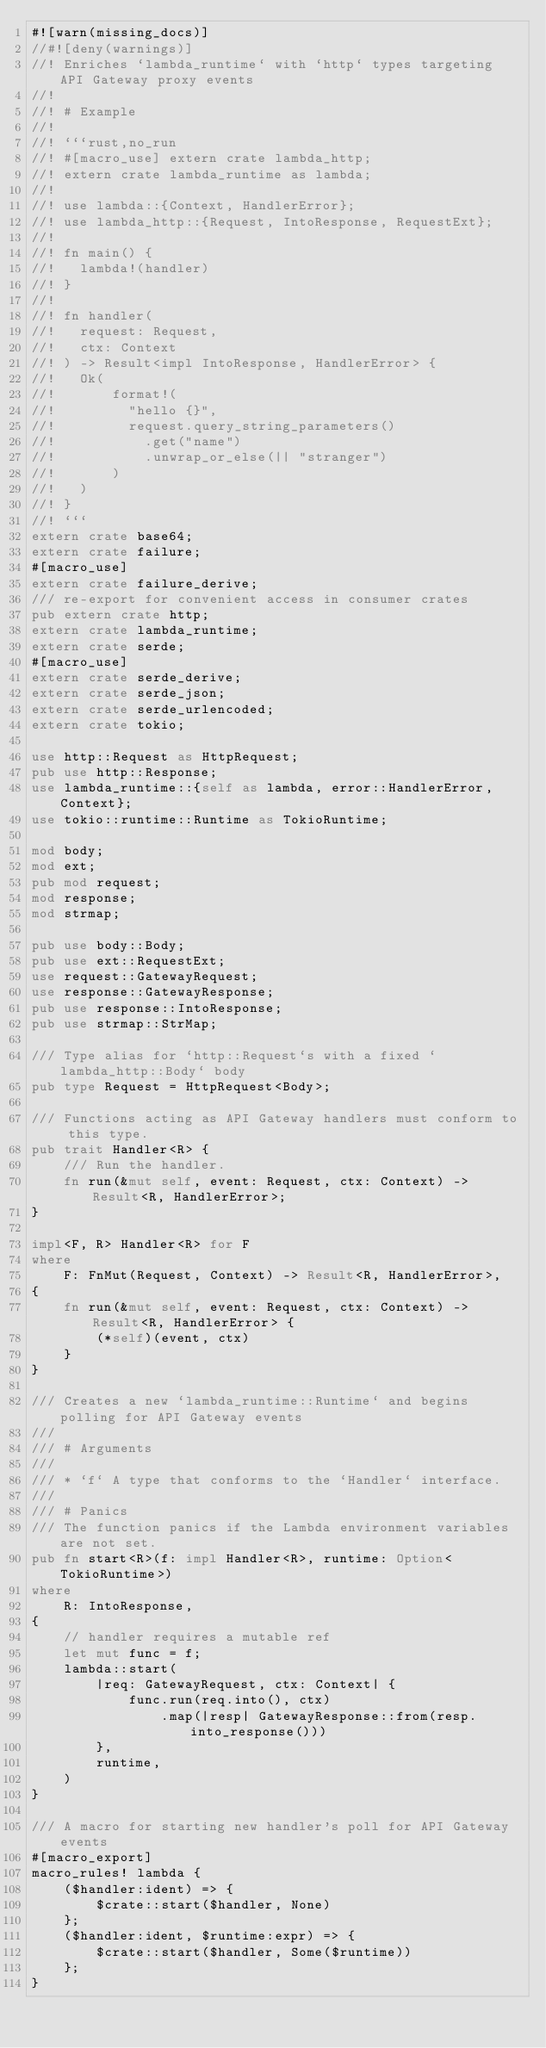<code> <loc_0><loc_0><loc_500><loc_500><_Rust_>#![warn(missing_docs)]
//#![deny(warnings)]
//! Enriches `lambda_runtime` with `http` types targeting API Gateway proxy events
//!
//! # Example
//!
//! ```rust,no_run
//! #[macro_use] extern crate lambda_http;
//! extern crate lambda_runtime as lambda;
//!
//! use lambda::{Context, HandlerError};
//! use lambda_http::{Request, IntoResponse, RequestExt};
//!
//! fn main() {
//!   lambda!(handler)
//! }
//!
//! fn handler(
//!   request: Request,
//!   ctx: Context
//! ) -> Result<impl IntoResponse, HandlerError> {
//!   Ok(
//!       format!(
//!         "hello {}",
//!         request.query_string_parameters()
//!           .get("name")
//!           .unwrap_or_else(|| "stranger")
//!       )
//!   )
//! }
//! ```
extern crate base64;
extern crate failure;
#[macro_use]
extern crate failure_derive;
/// re-export for convenient access in consumer crates
pub extern crate http;
extern crate lambda_runtime;
extern crate serde;
#[macro_use]
extern crate serde_derive;
extern crate serde_json;
extern crate serde_urlencoded;
extern crate tokio;

use http::Request as HttpRequest;
pub use http::Response;
use lambda_runtime::{self as lambda, error::HandlerError, Context};
use tokio::runtime::Runtime as TokioRuntime;

mod body;
mod ext;
pub mod request;
mod response;
mod strmap;

pub use body::Body;
pub use ext::RequestExt;
use request::GatewayRequest;
use response::GatewayResponse;
pub use response::IntoResponse;
pub use strmap::StrMap;

/// Type alias for `http::Request`s with a fixed `lambda_http::Body` body
pub type Request = HttpRequest<Body>;

/// Functions acting as API Gateway handlers must conform to this type.
pub trait Handler<R> {
    /// Run the handler.
    fn run(&mut self, event: Request, ctx: Context) -> Result<R, HandlerError>;
}

impl<F, R> Handler<R> for F
where
    F: FnMut(Request, Context) -> Result<R, HandlerError>,
{
    fn run(&mut self, event: Request, ctx: Context) -> Result<R, HandlerError> {
        (*self)(event, ctx)
    }
}

/// Creates a new `lambda_runtime::Runtime` and begins polling for API Gateway events
///
/// # Arguments
///
/// * `f` A type that conforms to the `Handler` interface.
///
/// # Panics
/// The function panics if the Lambda environment variables are not set.
pub fn start<R>(f: impl Handler<R>, runtime: Option<TokioRuntime>)
where
    R: IntoResponse,
{
    // handler requires a mutable ref
    let mut func = f;
    lambda::start(
        |req: GatewayRequest, ctx: Context| {
            func.run(req.into(), ctx)
                .map(|resp| GatewayResponse::from(resp.into_response()))
        },
        runtime,
    )
}

/// A macro for starting new handler's poll for API Gateway events
#[macro_export]
macro_rules! lambda {
    ($handler:ident) => {
        $crate::start($handler, None)
    };
    ($handler:ident, $runtime:expr) => {
        $crate::start($handler, Some($runtime))
    };
}
</code> 